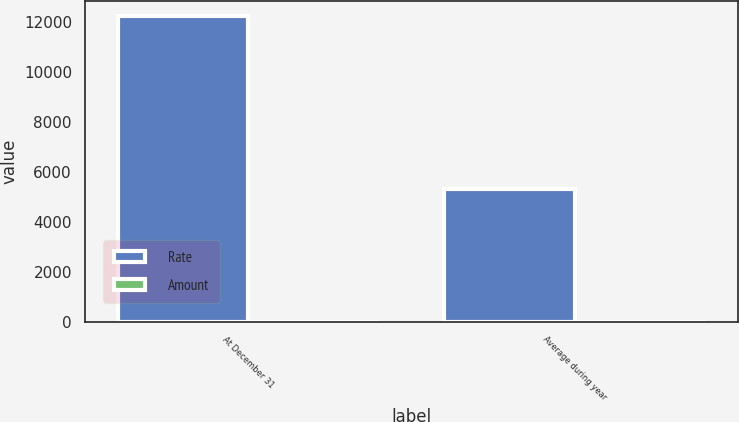<chart> <loc_0><loc_0><loc_500><loc_500><stacked_bar_chart><ecel><fcel>At December 31<fcel>Average during year<nl><fcel>Rate<fcel>12232<fcel>5292<nl><fcel>Amount<fcel>5.35<fcel>5.11<nl></chart> 